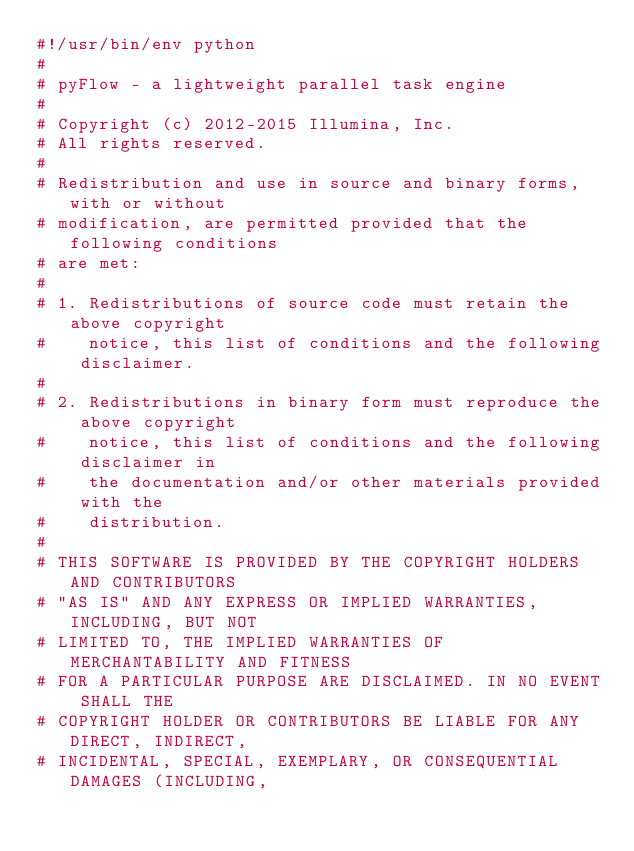<code> <loc_0><loc_0><loc_500><loc_500><_Python_>#!/usr/bin/env python
#
# pyFlow - a lightweight parallel task engine
#
# Copyright (c) 2012-2015 Illumina, Inc.
# All rights reserved.
#
# Redistribution and use in source and binary forms, with or without
# modification, are permitted provided that the following conditions
# are met:
#
# 1. Redistributions of source code must retain the above copyright
#    notice, this list of conditions and the following disclaimer.
#
# 2. Redistributions in binary form must reproduce the above copyright
#    notice, this list of conditions and the following disclaimer in
#    the documentation and/or other materials provided with the
#    distribution.
#
# THIS SOFTWARE IS PROVIDED BY THE COPYRIGHT HOLDERS AND CONTRIBUTORS
# "AS IS" AND ANY EXPRESS OR IMPLIED WARRANTIES, INCLUDING, BUT NOT
# LIMITED TO, THE IMPLIED WARRANTIES OF MERCHANTABILITY AND FITNESS
# FOR A PARTICULAR PURPOSE ARE DISCLAIMED. IN NO EVENT SHALL THE
# COPYRIGHT HOLDER OR CONTRIBUTORS BE LIABLE FOR ANY DIRECT, INDIRECT,
# INCIDENTAL, SPECIAL, EXEMPLARY, OR CONSEQUENTIAL DAMAGES (INCLUDING,</code> 